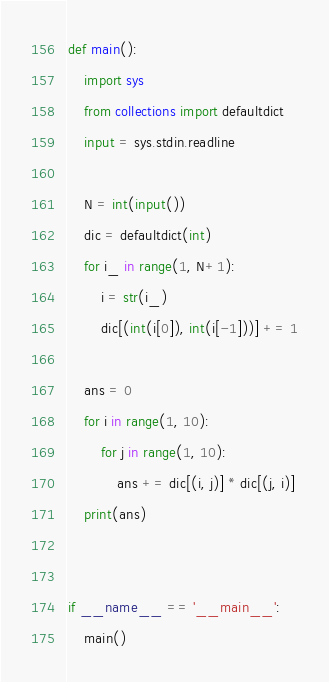<code> <loc_0><loc_0><loc_500><loc_500><_Python_>def main():
    import sys
    from collections import defaultdict
    input = sys.stdin.readline

    N = int(input())
    dic = defaultdict(int)
    for i_ in range(1, N+1):
        i = str(i_)
        dic[(int(i[0]), int(i[-1]))] += 1

    ans = 0
    for i in range(1, 10):
        for j in range(1, 10):
            ans += dic[(i, j)] * dic[(j, i)]
    print(ans)


if __name__ == '__main__':
    main()
</code> 